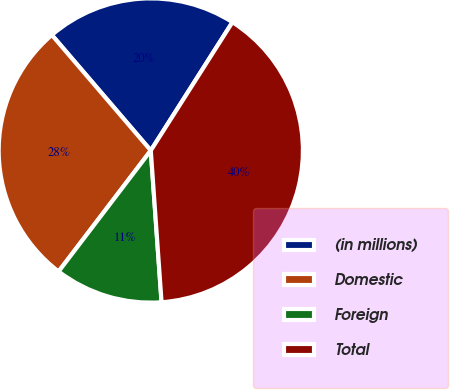Convert chart. <chart><loc_0><loc_0><loc_500><loc_500><pie_chart><fcel>(in millions)<fcel>Domestic<fcel>Foreign<fcel>Total<nl><fcel>20.29%<fcel>28.36%<fcel>11.49%<fcel>39.85%<nl></chart> 